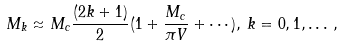<formula> <loc_0><loc_0><loc_500><loc_500>M _ { k } \approx M _ { c } \frac { ( 2 k + 1 ) } { 2 } ( 1 + \frac { M _ { c } } { \pi V } + \cdots ) , \, k = 0 , 1 , \dots \, ,</formula> 